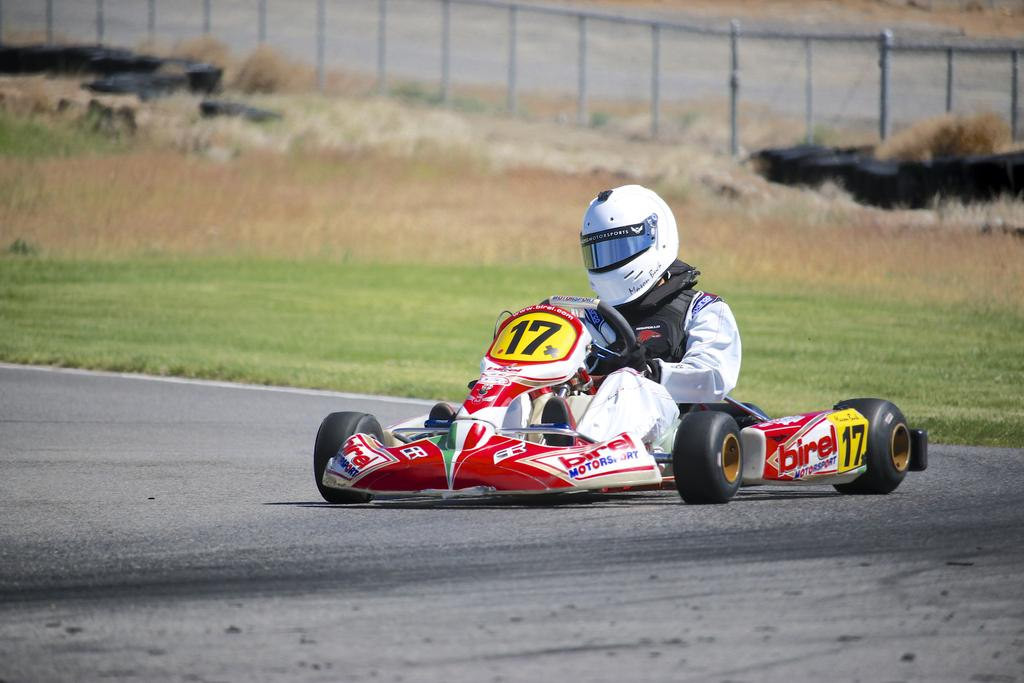What is the main subject of the image? There is a person driving a racing car in the image. Where is the car located? The car is on the road. What can be seen in the background of the image? There is grass and a fence in the background of the image. What type of paint is being used to write a prose on the fence in the image? There is no paint or prose present on the fence in the image. What order are the cars arranged in on the road in the image? The image only shows one car, so there is no order to be determined. 